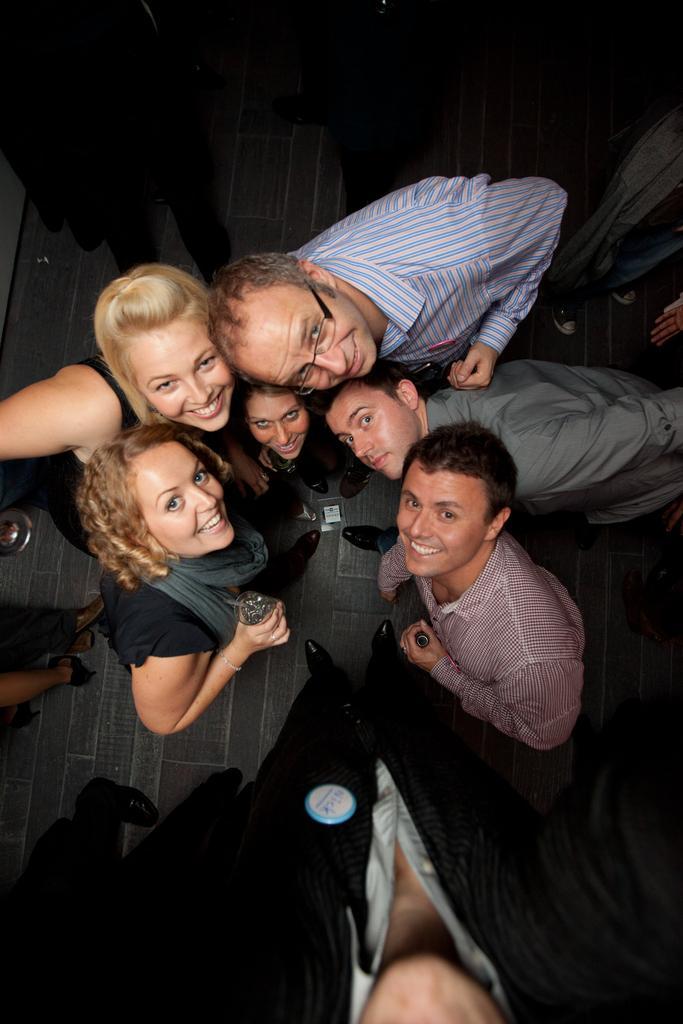Can you describe this image briefly? In this image we can see there are people standing on the floor and holding glass and bottle. 